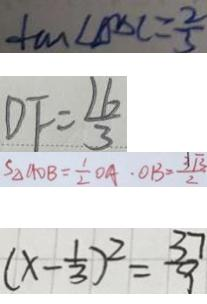<formula> <loc_0><loc_0><loc_500><loc_500>\tan \angle D D C = \frac { 2 } { 3 } 
 D F = \frac { 1 6 } { 3 } 
 S _ { \Delta A D B } = \frac { 1 } { 2 } O A \cdot O B = \frac { 3 \sqrt { 3 } } { 2 } 
 ( x - \frac { 1 } { 3 } ) ^ { 2 } = \frac { 3 7 } { 9 }</formula> 